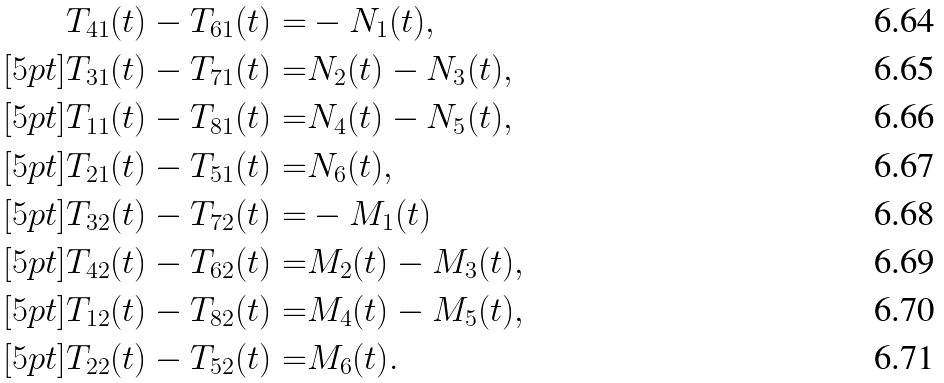<formula> <loc_0><loc_0><loc_500><loc_500>T _ { 4 1 } ( t ) - T _ { 6 1 } ( t ) = & - N _ { 1 } ( t ) , \\ [ 5 p t ] T _ { 3 1 } ( t ) - T _ { 7 1 } ( t ) = & N _ { 2 } ( t ) - N _ { 3 } ( t ) , \\ [ 5 p t ] T _ { 1 1 } ( t ) - T _ { 8 1 } ( t ) = & N _ { 4 } ( t ) - N _ { 5 } ( t ) , \\ [ 5 p t ] T _ { 2 1 } ( t ) - T _ { 5 1 } ( t ) = & N _ { 6 } ( t ) , \\ [ 5 p t ] T _ { 3 2 } ( t ) - T _ { 7 2 } ( t ) = & - M _ { 1 } ( t ) \\ [ 5 p t ] T _ { 4 2 } ( t ) - T _ { 6 2 } ( t ) = & M _ { 2 } ( t ) - M _ { 3 } ( t ) , \\ [ 5 p t ] T _ { 1 2 } ( t ) - T _ { 8 2 } ( t ) = & M _ { 4 } ( t ) - M _ { 5 } ( t ) , \\ [ 5 p t ] T _ { 2 2 } ( t ) - T _ { 5 2 } ( t ) = & M _ { 6 } ( t ) .</formula> 